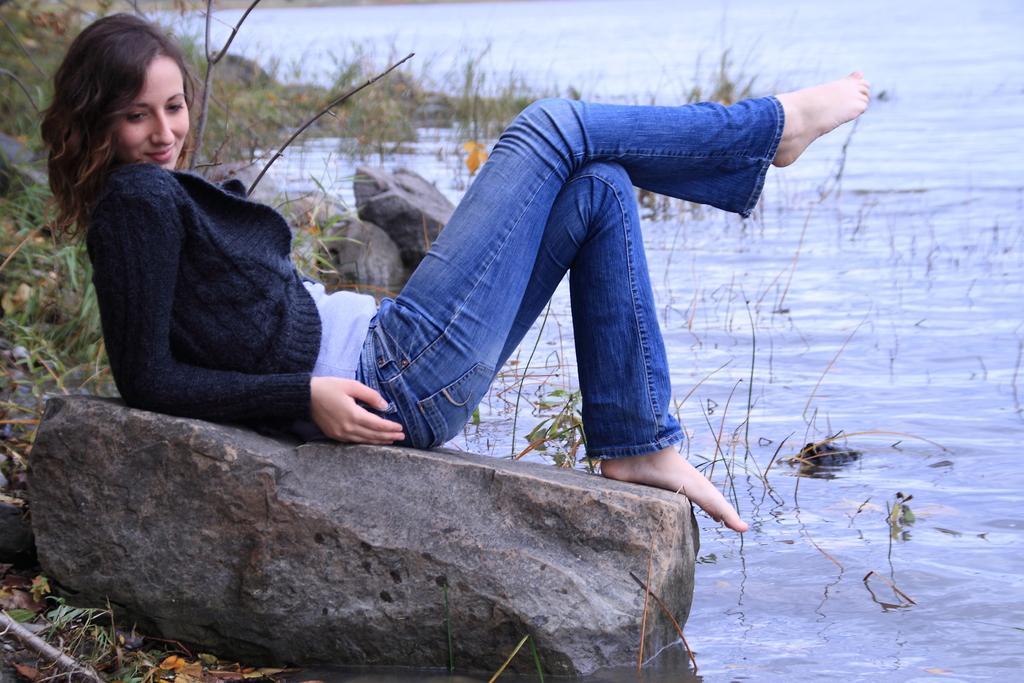Can you describe this image briefly? In this image there is a girl sitting on the stone. In front of her there is water in which there is grass. In the background there are stones and grass. 